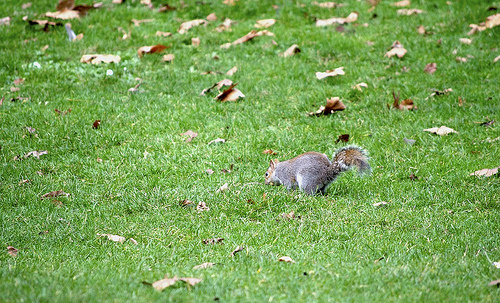<image>
Is the skirl behind the grass? No. The skirl is not behind the grass. From this viewpoint, the skirl appears to be positioned elsewhere in the scene. 